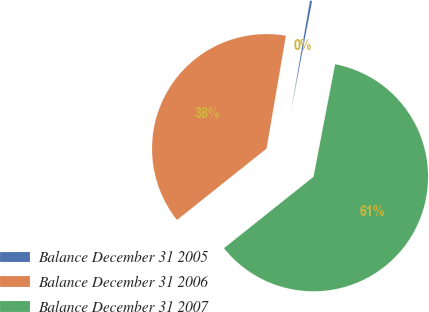Convert chart. <chart><loc_0><loc_0><loc_500><loc_500><pie_chart><fcel>Balance December 31 2005<fcel>Balance December 31 2006<fcel>Balance December 31 2007<nl><fcel>0.32%<fcel>38.41%<fcel>61.27%<nl></chart> 